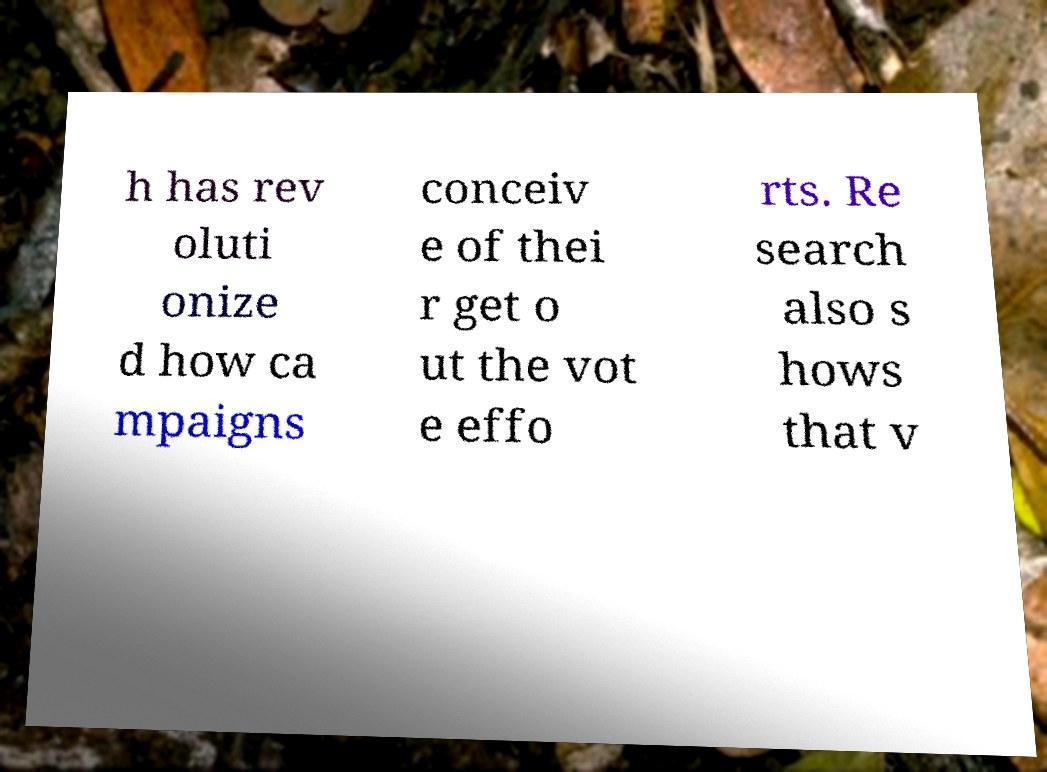Can you read and provide the text displayed in the image?This photo seems to have some interesting text. Can you extract and type it out for me? h has rev oluti onize d how ca mpaigns conceiv e of thei r get o ut the vot e effo rts. Re search also s hows that v 